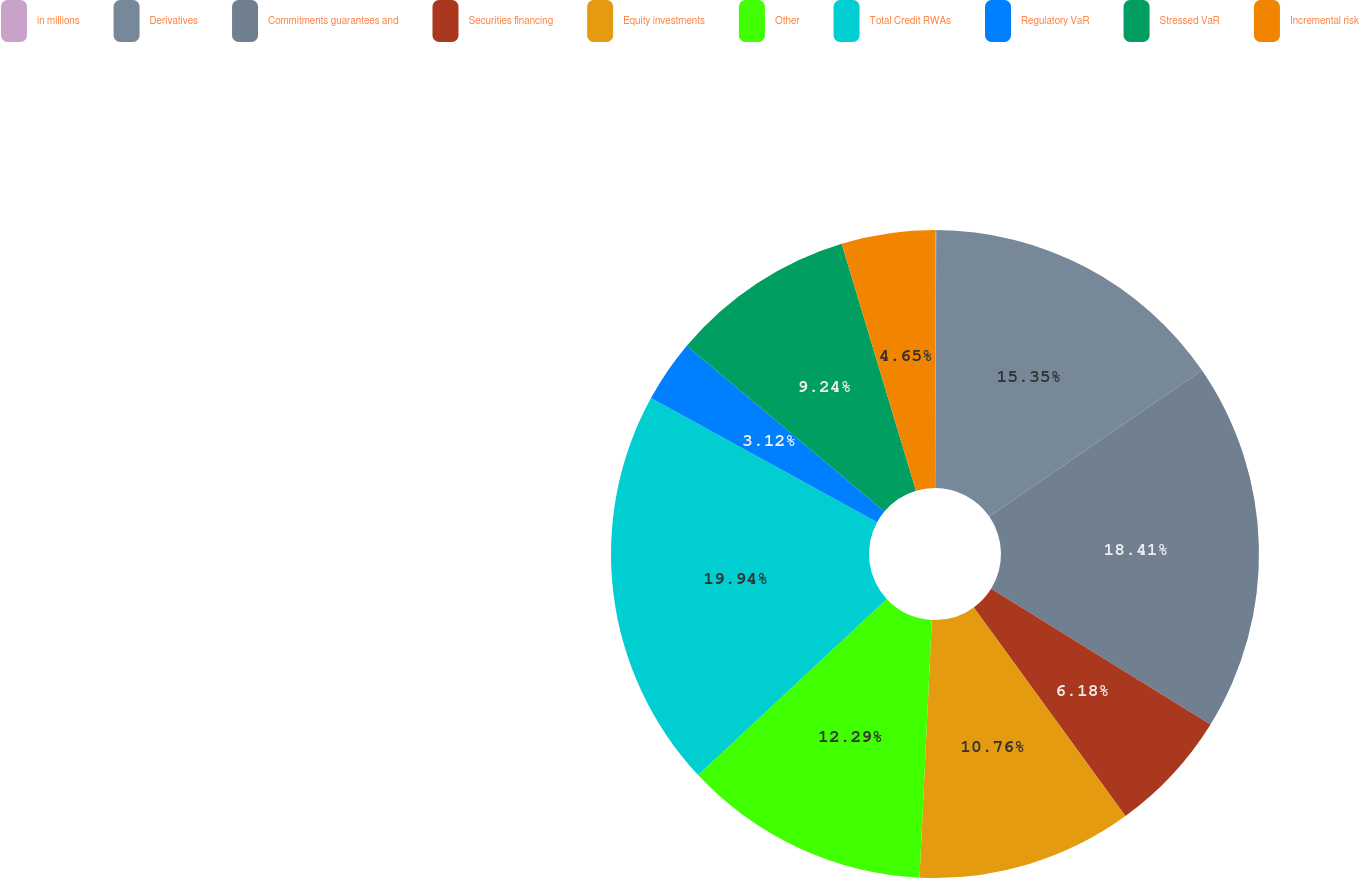Convert chart to OTSL. <chart><loc_0><loc_0><loc_500><loc_500><pie_chart><fcel>in millions<fcel>Derivatives<fcel>Commitments guarantees and<fcel>Securities financing<fcel>Equity investments<fcel>Other<fcel>Total Credit RWAs<fcel>Regulatory VaR<fcel>Stressed VaR<fcel>Incremental risk<nl><fcel>0.06%<fcel>15.35%<fcel>18.41%<fcel>6.18%<fcel>10.76%<fcel>12.29%<fcel>19.94%<fcel>3.12%<fcel>9.24%<fcel>4.65%<nl></chart> 